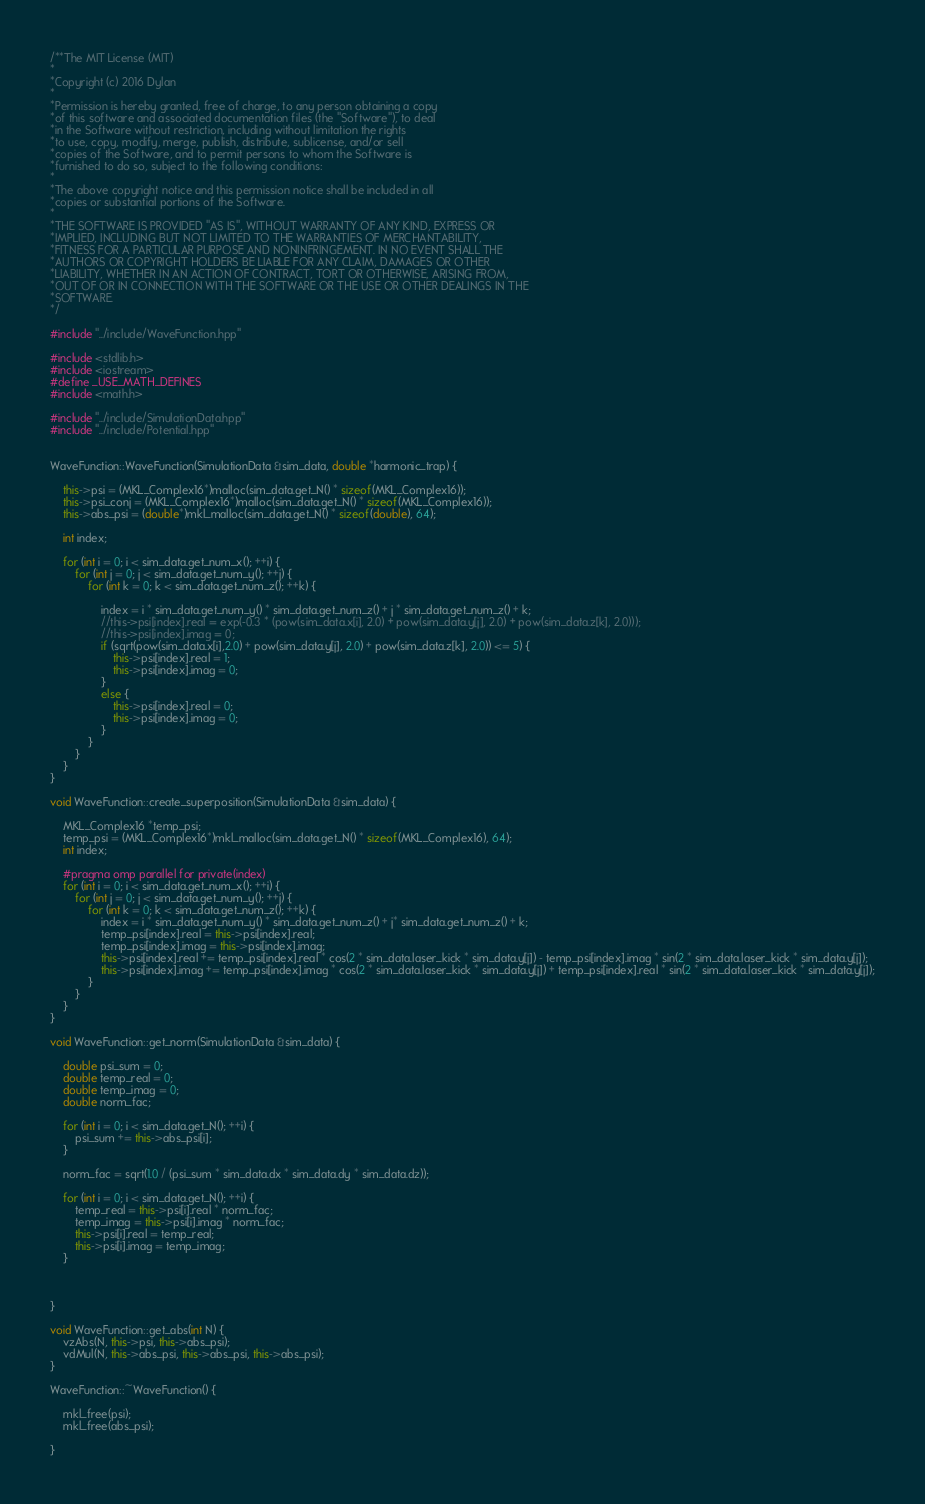<code> <loc_0><loc_0><loc_500><loc_500><_C++_>/**The MIT License (MIT)
*
*Copyright (c) 2016 Dylan
*
*Permission is hereby granted, free of charge, to any person obtaining a copy
*of this software and associated documentation files (the "Software"), to deal
*in the Software without restriction, including without limitation the rights
*to use, copy, modify, merge, publish, distribute, sublicense, and/or sell
*copies of the Software, and to permit persons to whom the Software is
*furnished to do so, subject to the following conditions:
*
*The above copyright notice and this permission notice shall be included in all
*copies or substantial portions of the Software.
*
*THE SOFTWARE IS PROVIDED "AS IS", WITHOUT WARRANTY OF ANY KIND, EXPRESS OR
*IMPLIED, INCLUDING BUT NOT LIMITED TO THE WARRANTIES OF MERCHANTABILITY,
*FITNESS FOR A PARTICULAR PURPOSE AND NONINFRINGEMENT. IN NO EVENT SHALL THE
*AUTHORS OR COPYRIGHT HOLDERS BE LIABLE FOR ANY CLAIM, DAMAGES OR OTHER
*LIABILITY, WHETHER IN AN ACTION OF CONTRACT, TORT OR OTHERWISE, ARISING FROM,
*OUT OF OR IN CONNECTION WITH THE SOFTWARE OR THE USE OR OTHER DEALINGS IN THE
*SOFTWARE.
*/

#include "../include/WaveFunction.hpp"

#include <stdlib.h>
#include <iostream>
#define _USE_MATH_DEFINES
#include <math.h>

#include "../include/SimulationData.hpp"
#include "../include/Potential.hpp"


WaveFunction::WaveFunction(SimulationData &sim_data, double *harmonic_trap) {

	this->psi = (MKL_Complex16*)malloc(sim_data.get_N() * sizeof(MKL_Complex16));	
	this->psi_conj = (MKL_Complex16*)malloc(sim_data.get_N() * sizeof(MKL_Complex16));	
	this->abs_psi = (double*)mkl_malloc(sim_data.get_N() * sizeof(double), 64);

	int index;

	for (int i = 0; i < sim_data.get_num_x(); ++i) {
		for (int j = 0; j < sim_data.get_num_y(); ++j) {
			for (int k = 0; k < sim_data.get_num_z(); ++k) {

				index = i * sim_data.get_num_y() * sim_data.get_num_z() + j * sim_data.get_num_z() + k;
				//this->psi[index].real = exp(-0.3 * (pow(sim_data.x[i], 2.0) + pow(sim_data.y[j], 2.0) + pow(sim_data.z[k], 2.0)));
				//this->psi[index].imag = 0;
				if (sqrt(pow(sim_data.x[i],2.0) + pow(sim_data.y[j], 2.0) + pow(sim_data.z[k], 2.0)) <= 5) {
					this->psi[index].real = 1;
					this->psi[index].imag = 0;
				}
				else {
					this->psi[index].real = 0;
					this->psi[index].imag = 0;
				}
			}
		}
	}
}

void WaveFunction::create_superposition(SimulationData &sim_data) {

	MKL_Complex16 *temp_psi;
	temp_psi = (MKL_Complex16*)mkl_malloc(sim_data.get_N() * sizeof(MKL_Complex16), 64);
	int index;
	
	#pragma omp parallel for private(index)
	for (int i = 0; i < sim_data.get_num_x(); ++i) {
		for (int j = 0; j < sim_data.get_num_y(); ++j) {
			for (int k = 0; k < sim_data.get_num_z(); ++k) {
				index = i * sim_data.get_num_y() * sim_data.get_num_z() + j* sim_data.get_num_z() + k;
				temp_psi[index].real = this->psi[index].real;
				temp_psi[index].imag = this->psi[index].imag;
				this->psi[index].real += temp_psi[index].real * cos(2 * sim_data.laser_kick * sim_data.y[j]) - temp_psi[index].imag * sin(2 * sim_data.laser_kick * sim_data.y[j]);
				this->psi[index].imag += temp_psi[index].imag * cos(2 * sim_data.laser_kick * sim_data.y[j]) + temp_psi[index].real * sin(2 * sim_data.laser_kick * sim_data.y[j]);
			}
		}
	}
}

void WaveFunction::get_norm(SimulationData &sim_data) {

	double psi_sum = 0;
	double temp_real = 0;
	double temp_imag = 0;
	double norm_fac;
	
	for (int i = 0; i < sim_data.get_N(); ++i) {
		psi_sum += this->abs_psi[i];
	}

	norm_fac = sqrt(1.0 / (psi_sum * sim_data.dx * sim_data.dy * sim_data.dz));
	
	for (int i = 0; i < sim_data.get_N(); ++i) {
		temp_real = this->psi[i].real * norm_fac;
		temp_imag = this->psi[i].imag * norm_fac;
		this->psi[i].real = temp_real;
		this->psi[i].imag = temp_imag;
	}


	
}

void WaveFunction::get_abs(int N) {
	vzAbs(N, this->psi, this->abs_psi);
	vdMul(N, this->abs_psi, this->abs_psi, this->abs_psi);
}

WaveFunction::~WaveFunction() {
	
	mkl_free(psi);
	mkl_free(abs_psi);

}
</code> 